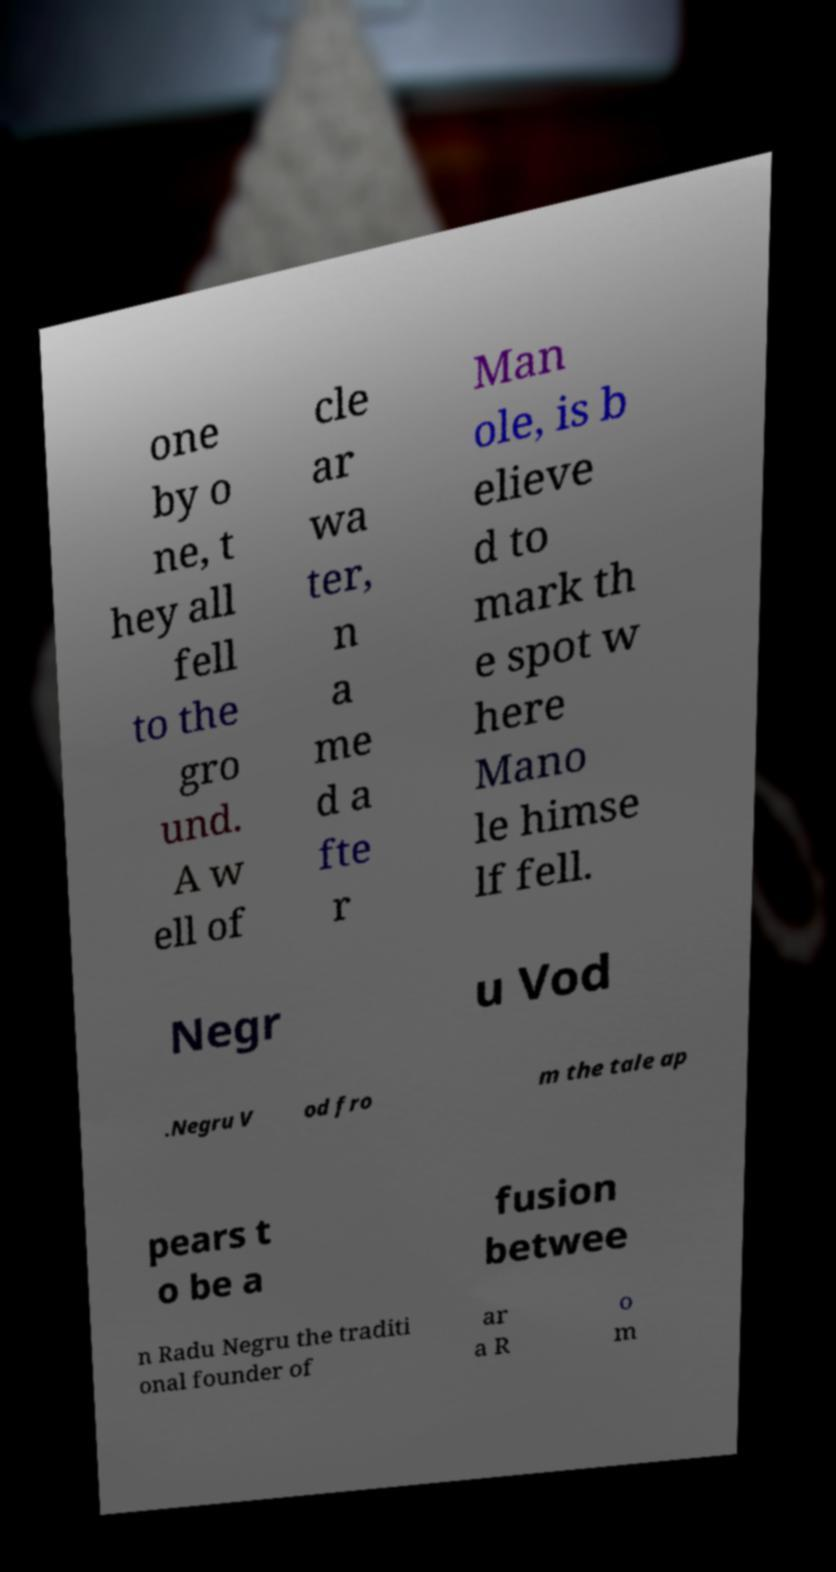Could you extract and type out the text from this image? one by o ne, t hey all fell to the gro und. A w ell of cle ar wa ter, n a me d a fte r Man ole, is b elieve d to mark th e spot w here Mano le himse lf fell. Negr u Vod .Negru V od fro m the tale ap pears t o be a fusion betwee n Radu Negru the traditi onal founder of ar a R o m 